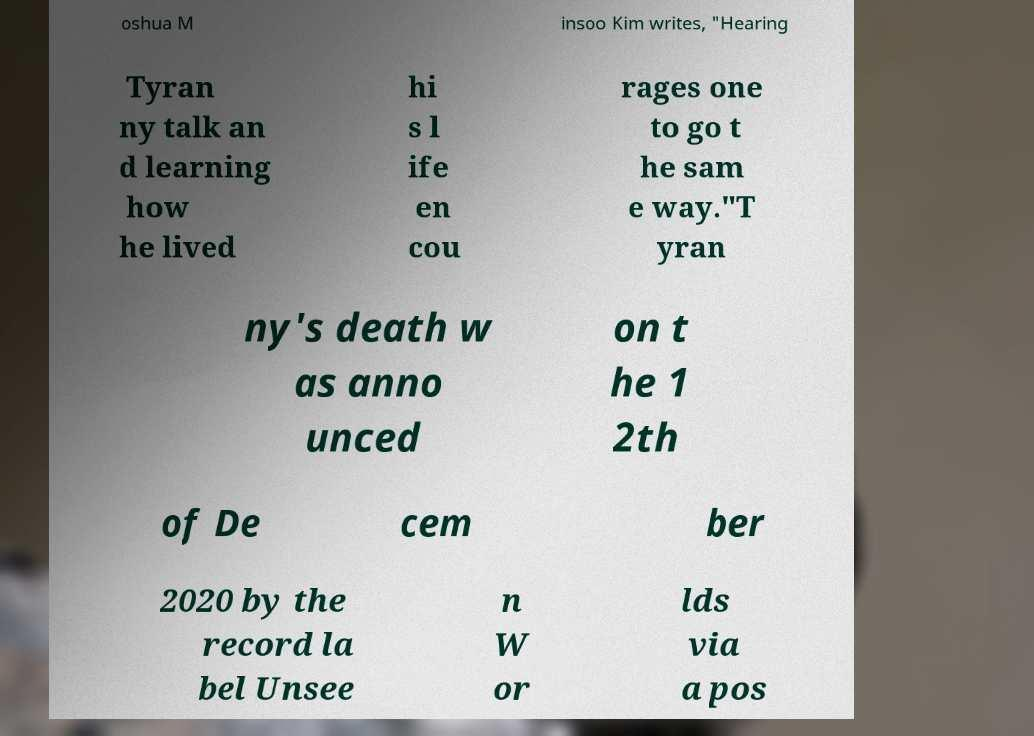Please read and relay the text visible in this image. What does it say? oshua M insoo Kim writes, "Hearing Tyran ny talk an d learning how he lived hi s l ife en cou rages one to go t he sam e way."T yran ny's death w as anno unced on t he 1 2th of De cem ber 2020 by the record la bel Unsee n W or lds via a pos 